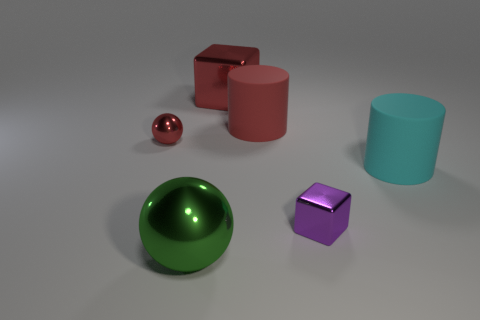What is the material of the tiny red object?
Make the answer very short. Metal. What is the material of the red ball that is the same size as the purple thing?
Your response must be concise. Metal. Is there a green cylinder of the same size as the green ball?
Make the answer very short. No. Is the number of metal blocks behind the cyan thing the same as the number of large cubes that are behind the large red matte thing?
Your response must be concise. Yes. Are there more large balls than spheres?
Provide a succinct answer. No. What number of rubber objects are either tiny red objects or large gray objects?
Offer a very short reply. 0. What number of big cylinders have the same color as the tiny block?
Ensure brevity in your answer.  0. What material is the red thing that is to the right of the big metal thing behind the shiny object on the right side of the red cylinder?
Offer a terse response. Rubber. What is the color of the metal cube that is in front of the large shiny object that is to the right of the green thing?
Offer a very short reply. Purple. What number of small objects are either metallic cubes or red cubes?
Your answer should be compact. 1. 